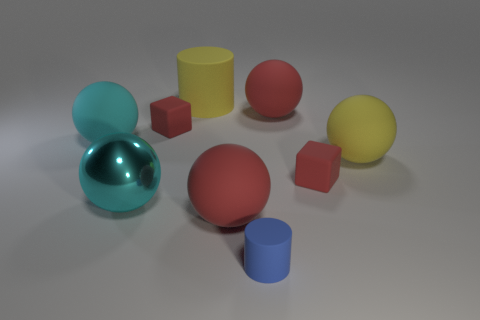Does the red thing that is in front of the shiny thing have the same size as the cyan matte thing?
Make the answer very short. Yes. What number of blocks are either large cyan rubber things or red objects?
Provide a short and direct response. 2. What material is the large cyan thing that is in front of the large yellow ball?
Your response must be concise. Metal. Is the number of small rubber objects less than the number of yellow rubber things?
Provide a succinct answer. No. There is a thing that is to the right of the large metal ball and left of the yellow matte cylinder; how big is it?
Your answer should be compact. Small. There is a red matte cube that is in front of the large yellow thing that is to the right of the red block on the right side of the blue rubber thing; what is its size?
Provide a short and direct response. Small. How many other things are there of the same color as the small cylinder?
Your answer should be very brief. 0. Do the matte ball on the left side of the big cylinder and the large metallic sphere have the same color?
Your answer should be very brief. Yes. What number of objects are either balls or cyan matte spheres?
Provide a short and direct response. 5. There is a matte cylinder in front of the yellow ball; what is its color?
Your answer should be compact. Blue. 